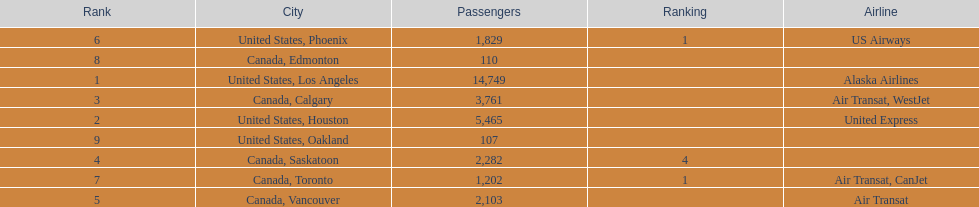What numbers are in the passengers column? 14,749, 5,465, 3,761, 2,282, 2,103, 1,829, 1,202, 110, 107. Which number is the lowest number in the passengers column? 107. What city is associated with this number? United States, Oakland. 